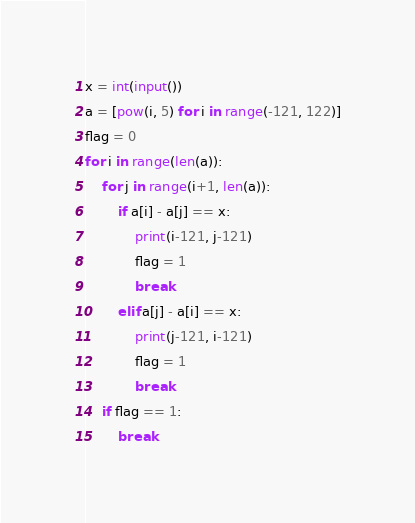Convert code to text. <code><loc_0><loc_0><loc_500><loc_500><_Python_>x = int(input())
a = [pow(i, 5) for i in range(-121, 122)]
flag = 0
for i in range(len(a)):
    for j in range(i+1, len(a)):
        if a[i] - a[j] == x:
            print(i-121, j-121)
            flag = 1
            break
        elif a[j] - a[i] == x:
            print(j-121, i-121)
            flag = 1
            break
    if flag == 1:
        break</code> 